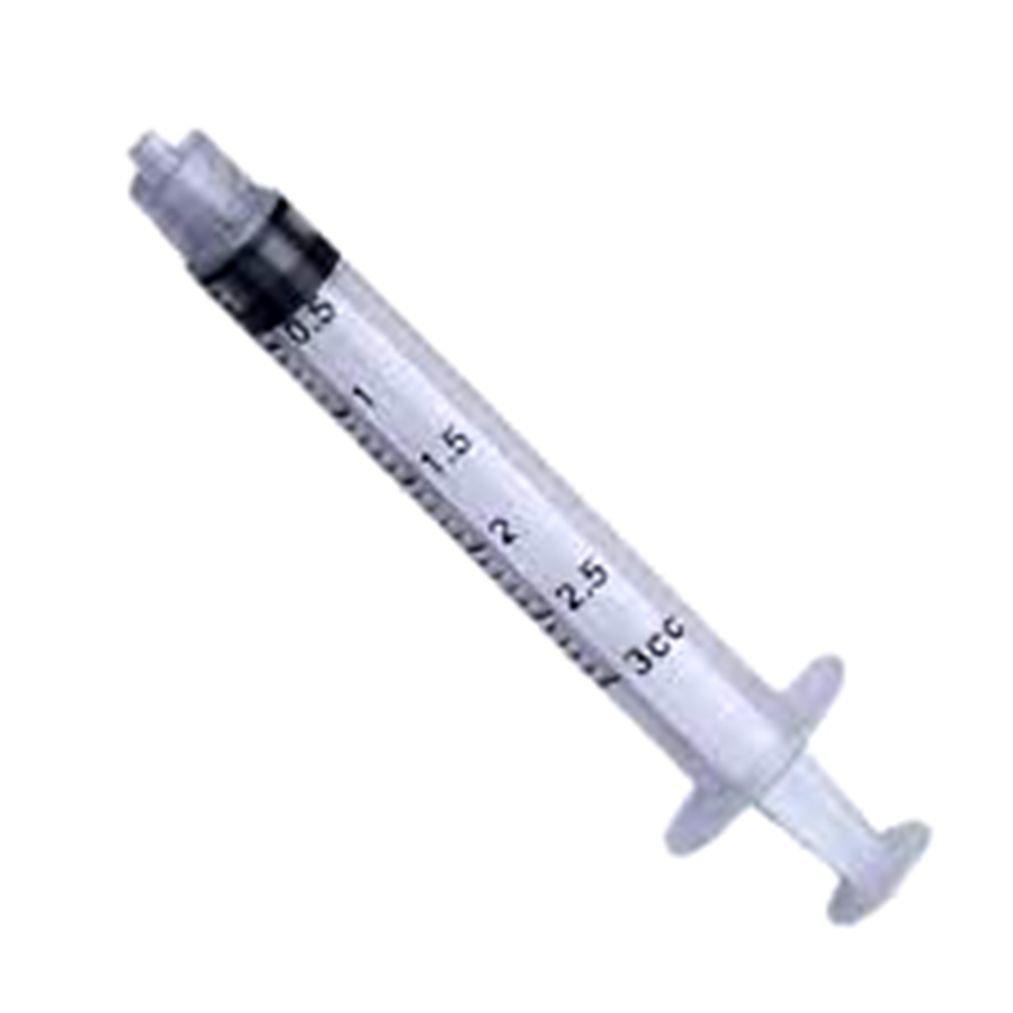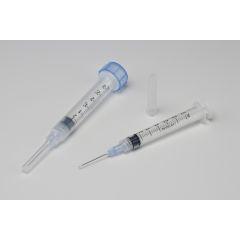The first image is the image on the left, the second image is the image on the right. For the images shown, is this caption "The combined images include a white wrapper and an upright blue lid behind a syringe with an exposed tip." true? Answer yes or no. No. The first image is the image on the left, the second image is the image on the right. Analyze the images presented: Is the assertion "A blue cap is next to at least 1 syringe with a needle." valid? Answer yes or no. No. 